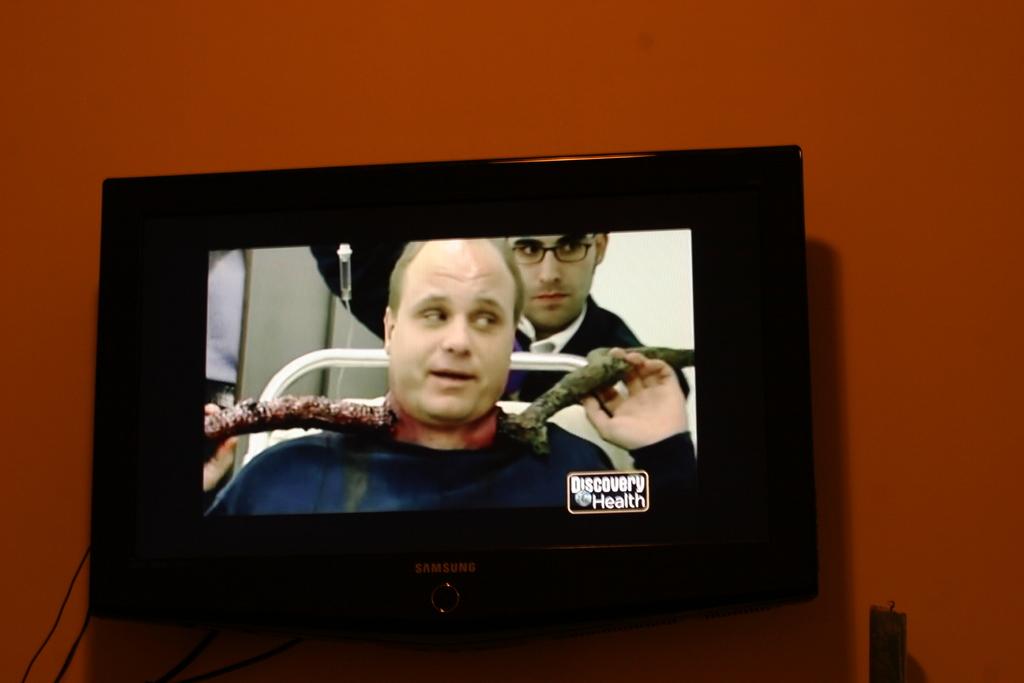What channel is on the tv?
Your response must be concise. Discovery health. 